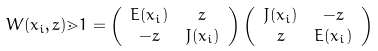<formula> <loc_0><loc_0><loc_500><loc_500>W ( x _ { i } , z ) \mathbb { m } { 1 } & = \left ( \begin{array} { c c } E ( x _ { i } ) & z \\ - z & J ( x _ { i } ) \end{array} \right ) \left ( \begin{array} { c c } J ( x _ { i } ) & - z \\ z & E ( x _ { i } ) \end{array} \right )</formula> 